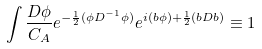<formula> <loc_0><loc_0><loc_500><loc_500>\int \frac { D \phi } { C _ { A } } e ^ { - \frac { 1 } { 2 } ( \phi D ^ { - 1 } \phi ) } e ^ { i ( b \phi ) + \frac { 1 } { 2 } ( b D b ) } \equiv 1</formula> 